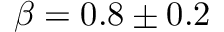Convert formula to latex. <formula><loc_0><loc_0><loc_500><loc_500>\beta = 0 . 8 \pm 0 . 2</formula> 